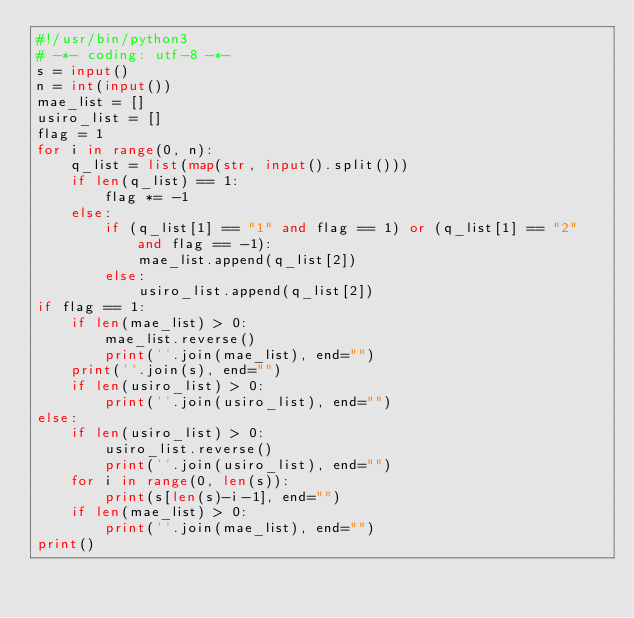<code> <loc_0><loc_0><loc_500><loc_500><_Python_>#!/usr/bin/python3
# -*- coding: utf-8 -*-
s = input()
n = int(input())
mae_list = []
usiro_list = []
flag = 1
for i in range(0, n):
    q_list = list(map(str, input().split()))
    if len(q_list) == 1:
        flag *= -1
    else:
        if (q_list[1] == "1" and flag == 1) or (q_list[1] == "2" and flag == -1):
            mae_list.append(q_list[2])
        else:
            usiro_list.append(q_list[2])
if flag == 1:
    if len(mae_list) > 0:
        mae_list.reverse()
        print(''.join(mae_list), end="")
    print(''.join(s), end="")
    if len(usiro_list) > 0:
        print(''.join(usiro_list), end="")
else:
    if len(usiro_list) > 0:
        usiro_list.reverse()
        print(''.join(usiro_list), end="")
    for i in range(0, len(s)):
        print(s[len(s)-i-1], end="")
    if len(mae_list) > 0:
        print(''.join(mae_list), end="")
print()</code> 